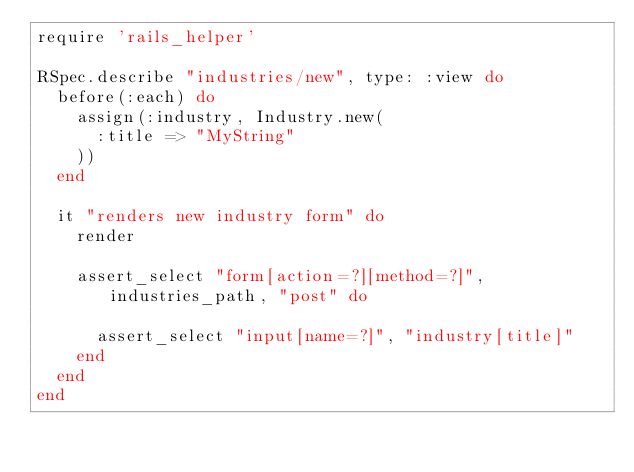Convert code to text. <code><loc_0><loc_0><loc_500><loc_500><_Ruby_>require 'rails_helper'

RSpec.describe "industries/new", type: :view do
  before(:each) do
    assign(:industry, Industry.new(
      :title => "MyString"
    ))
  end

  it "renders new industry form" do
    render

    assert_select "form[action=?][method=?]", industries_path, "post" do

      assert_select "input[name=?]", "industry[title]"
    end
  end
end
</code> 